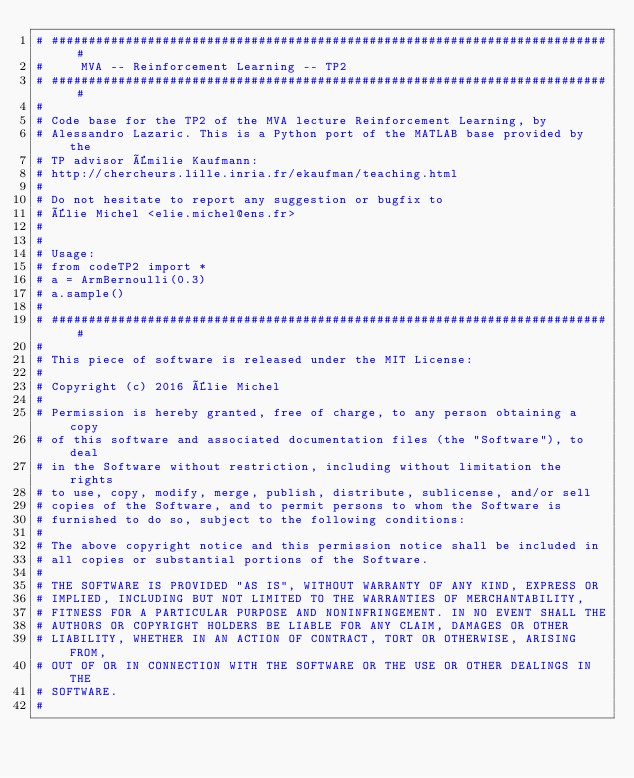Convert code to text. <code><loc_0><loc_0><loc_500><loc_500><_Python_># ########################################################################### #
#     MVA -- Reinforcement Learning -- TP2
# ########################################################################### #
#
# Code base for the TP2 of the MVA lecture Reinforcement Learning, by
# Alessandro Lazaric. This is a Python port of the MATLAB base provided by the
# TP advisor Émilie Kaufmann:
# http://chercheurs.lille.inria.fr/ekaufman/teaching.html
#
# Do not hesitate to report any suggestion or bugfix to
# Élie Michel <elie.michel@ens.fr>
# 
# 
# Usage:
# from codeTP2 import *
# a = ArmBernoulli(0.3)
# a.sample()
#
# ########################################################################### #
#
# This piece of software is released under the MIT License:
#
# Copyright (c) 2016 Élie Michel
#
# Permission is hereby granted, free of charge, to any person obtaining a copy
# of this software and associated documentation files (the "Software"), to deal
# in the Software without restriction, including without limitation the rights
# to use, copy, modify, merge, publish, distribute, sublicense, and/or sell
# copies of the Software, and to permit persons to whom the Software is
# furnished to do so, subject to the following conditions:
#
# The above copyright notice and this permission notice shall be included in
# all copies or substantial portions of the Software.
#
# THE SOFTWARE IS PROVIDED "AS IS", WITHOUT WARRANTY OF ANY KIND, EXPRESS OR
# IMPLIED, INCLUDING BUT NOT LIMITED TO THE WARRANTIES OF MERCHANTABILITY,
# FITNESS FOR A PARTICULAR PURPOSE AND NONINFRINGEMENT. IN NO EVENT SHALL THE
# AUTHORS OR COPYRIGHT HOLDERS BE LIABLE FOR ANY CLAIM, DAMAGES OR OTHER
# LIABILITY, WHETHER IN AN ACTION OF CONTRACT, TORT OR OTHERWISE, ARISING FROM,
# OUT OF OR IN CONNECTION WITH THE SOFTWARE OR THE USE OR OTHER DEALINGS IN THE
# SOFTWARE.
#</code> 